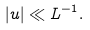<formula> <loc_0><loc_0><loc_500><loc_500>| u | \ll L ^ { - 1 } .</formula> 